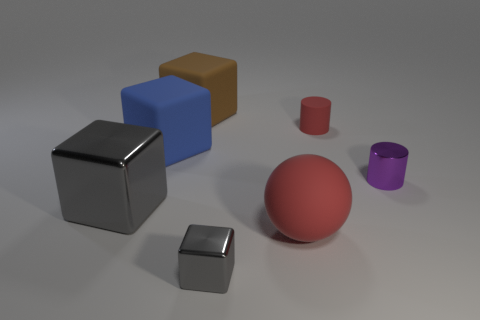Do the red cylinder and the thing that is right of the red cylinder have the same size?
Give a very brief answer. Yes. There is a thing that is left of the red sphere and in front of the big shiny cube; what is its shape?
Ensure brevity in your answer.  Cube. What is the size of the ball that is made of the same material as the blue object?
Provide a short and direct response. Large. There is a small shiny cube that is left of the tiny matte thing; what number of metallic things are behind it?
Make the answer very short. 2. Is the material of the tiny thing that is in front of the large rubber ball the same as the purple object?
Provide a short and direct response. Yes. There is a gray block to the right of the big matte block on the left side of the brown matte cube; what is its size?
Offer a very short reply. Small. There is a metal object on the right side of the tiny thing on the left side of the tiny thing behind the tiny metallic cylinder; what is its size?
Ensure brevity in your answer.  Small. Does the shiny thing behind the large gray block have the same shape as the red thing that is behind the small purple thing?
Make the answer very short. Yes. How many other things are there of the same color as the rubber cylinder?
Ensure brevity in your answer.  1. Is the size of the gray shiny object left of the brown rubber block the same as the matte sphere?
Ensure brevity in your answer.  Yes. 